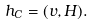Convert formula to latex. <formula><loc_0><loc_0><loc_500><loc_500>h _ { C } = ( v , H ) .</formula> 